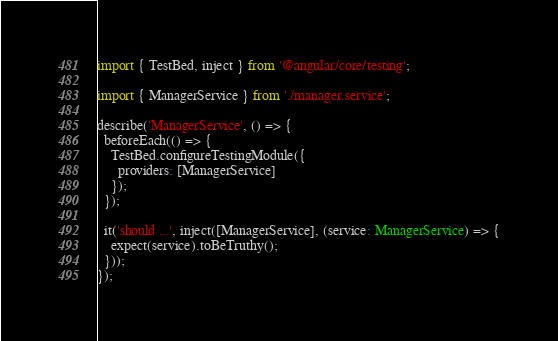Convert code to text. <code><loc_0><loc_0><loc_500><loc_500><_TypeScript_>import { TestBed, inject } from '@angular/core/testing';

import { ManagerService } from './manager.service';

describe('ManagerService', () => {
  beforeEach(() => {
    TestBed.configureTestingModule({
      providers: [ManagerService]
    });
  });

  it('should ...', inject([ManagerService], (service: ManagerService) => {
    expect(service).toBeTruthy();
  }));
});
</code> 